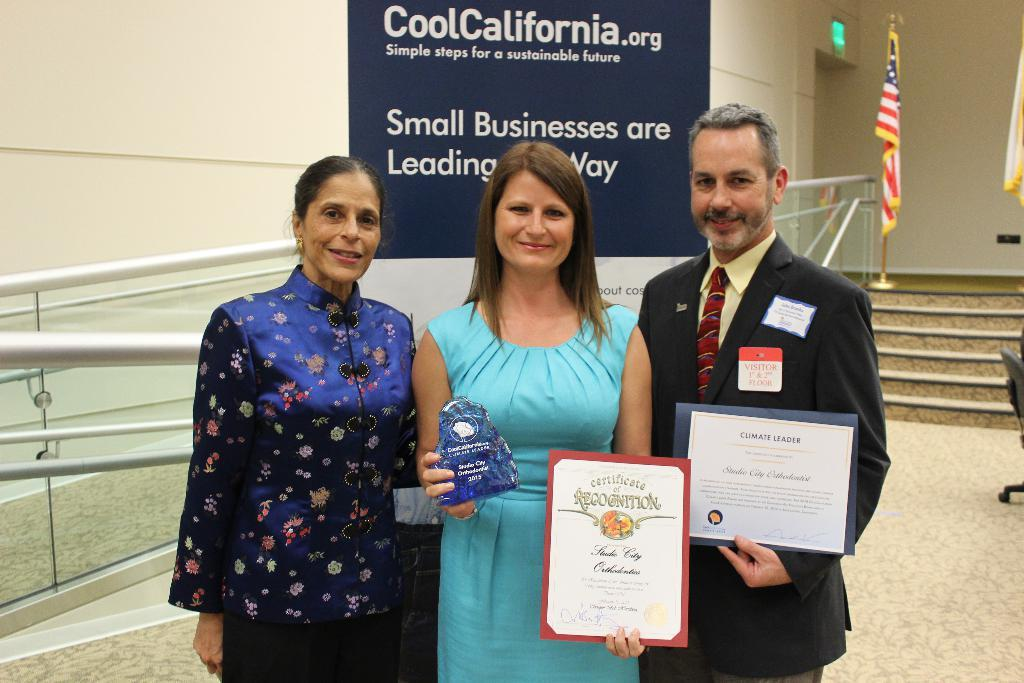How many people are in the image? There are three persons in the image. What is one person holding in the image? One person is holding a shield. What can be seen in the background of the image? There is a wall, a flag, and steps in the background of the image. What is attached to the wall in the image? There is a banner attached to the wall. What is written on the banner? There is text on the banner. Can you see a cart being pushed by one of the persons in the image? No, there is no cart present in the image. Are the persons in the image saying good-bye to someone? There is no indication in the image that the persons are saying good-bye to someone. 